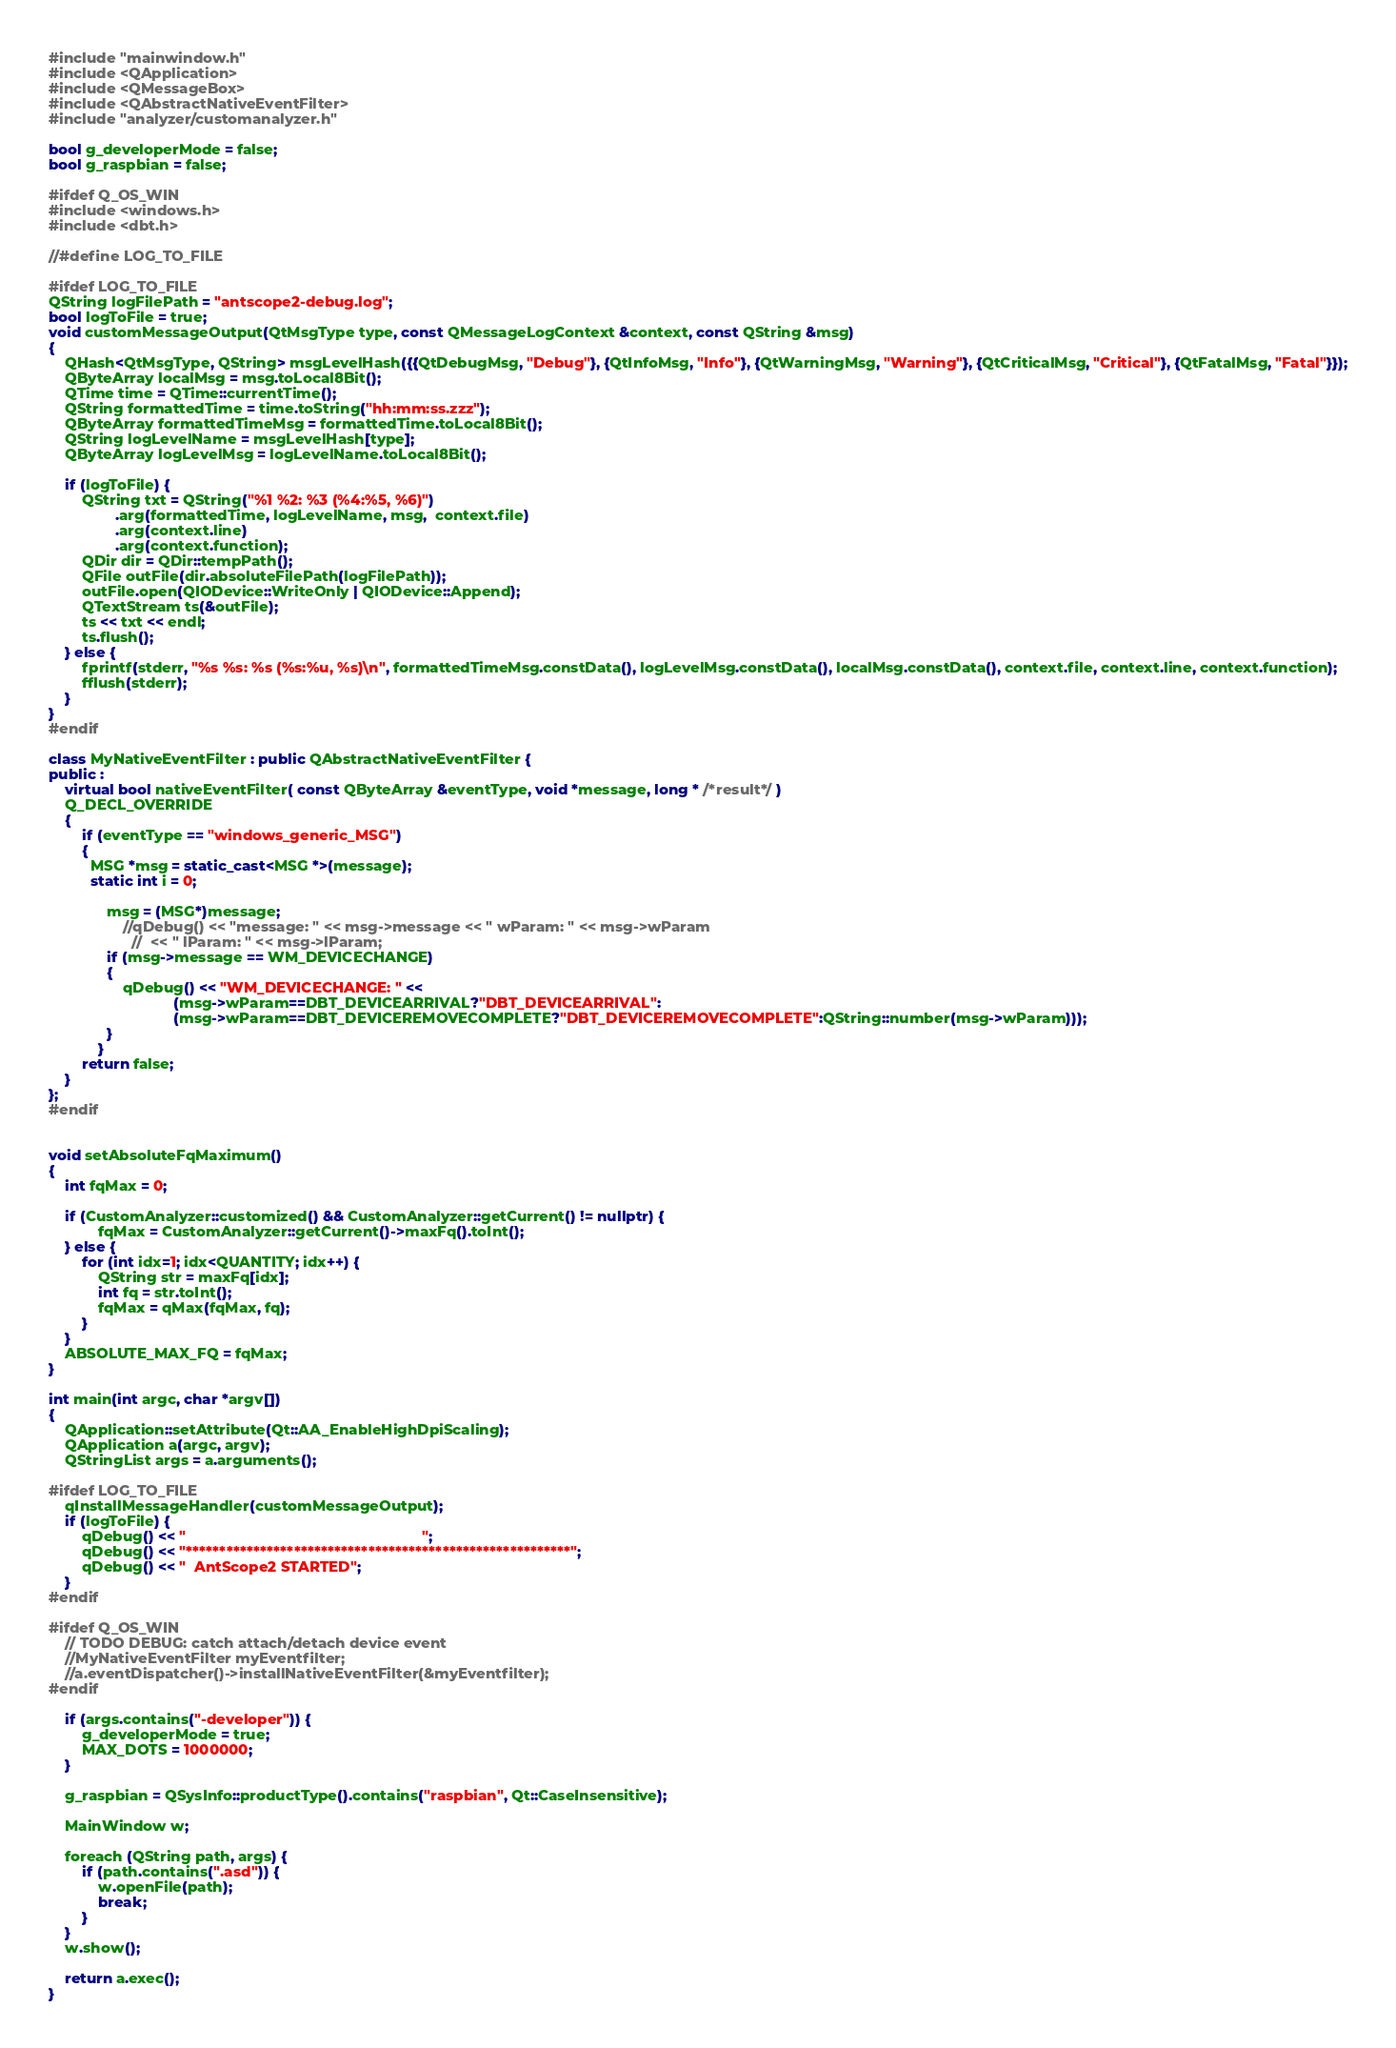Convert code to text. <code><loc_0><loc_0><loc_500><loc_500><_C++_>#include "mainwindow.h"
#include <QApplication>
#include <QMessageBox>
#include <QAbstractNativeEventFilter>
#include "analyzer/customanalyzer.h"

bool g_developerMode = false;
bool g_raspbian = false;

#ifdef Q_OS_WIN
#include <windows.h>
#include <dbt.h>

//#define LOG_TO_FILE

#ifdef LOG_TO_FILE
QString logFilePath = "antscope2-debug.log";
bool logToFile = true;
void customMessageOutput(QtMsgType type, const QMessageLogContext &context, const QString &msg)
{
    QHash<QtMsgType, QString> msgLevelHash({{QtDebugMsg, "Debug"}, {QtInfoMsg, "Info"}, {QtWarningMsg, "Warning"}, {QtCriticalMsg, "Critical"}, {QtFatalMsg, "Fatal"}});
    QByteArray localMsg = msg.toLocal8Bit();
    QTime time = QTime::currentTime();
    QString formattedTime = time.toString("hh:mm:ss.zzz");
    QByteArray formattedTimeMsg = formattedTime.toLocal8Bit();
    QString logLevelName = msgLevelHash[type];
    QByteArray logLevelMsg = logLevelName.toLocal8Bit();

    if (logToFile) {
        QString txt = QString("%1 %2: %3 (%4:%5, %6)")
                .arg(formattedTime, logLevelName, msg,  context.file)
                .arg(context.line)
                .arg(context.function);
        QDir dir = QDir::tempPath();
        QFile outFile(dir.absoluteFilePath(logFilePath));
        outFile.open(QIODevice::WriteOnly | QIODevice::Append);
        QTextStream ts(&outFile);
        ts << txt << endl;
        ts.flush();
    } else {
        fprintf(stderr, "%s %s: %s (%s:%u, %s)\n", formattedTimeMsg.constData(), logLevelMsg.constData(), localMsg.constData(), context.file, context.line, context.function);
        fflush(stderr);
    }
}
#endif

class MyNativeEventFilter : public QAbstractNativeEventFilter {
public :
    virtual bool nativeEventFilter( const QByteArray &eventType, void *message, long * /*result*/ )
    Q_DECL_OVERRIDE
    {
        if (eventType == "windows_generic_MSG")
        {
          MSG *msg = static_cast<MSG *>(message);
          static int i = 0;

              msg = (MSG*)message;
                  //qDebug() << "message: " << msg->message << " wParam: " << msg->wParam
                    //  << " lParam: " << msg->lParam;
              if (msg->message == WM_DEVICECHANGE)
              {
                  qDebug() << "WM_DEVICECHANGE: " <<
                              (msg->wParam==DBT_DEVICEARRIVAL?"DBT_DEVICEARRIVAL":
                              (msg->wParam==DBT_DEVICEREMOVECOMPLETE?"DBT_DEVICEREMOVECOMPLETE":QString::number(msg->wParam)));
              }
            }
        return false;
    }
};
#endif


void setAbsoluteFqMaximum()
{
    int fqMax = 0;

    if (CustomAnalyzer::customized() && CustomAnalyzer::getCurrent() != nullptr) {
            fqMax = CustomAnalyzer::getCurrent()->maxFq().toInt();
    } else {
        for (int idx=1; idx<QUANTITY; idx++) {
            QString str = maxFq[idx];
            int fq = str.toInt();
            fqMax = qMax(fqMax, fq);
        }
    }
    ABSOLUTE_MAX_FQ = fqMax;
}

int main(int argc, char *argv[])
{
    QApplication::setAttribute(Qt::AA_EnableHighDpiScaling);
    QApplication a(argc, argv);
    QStringList args = a.arguments();

#ifdef LOG_TO_FILE
    qInstallMessageHandler(customMessageOutput);
    if (logToFile) {
        qDebug() << "                                                         ";
        qDebug() << "*********************************************************";
        qDebug() << "  AntScope2 STARTED";
    }
#endif

#ifdef Q_OS_WIN
    // TODO DEBUG: catch attach/detach device event
    //MyNativeEventFilter myEventfilter;
    //a.eventDispatcher()->installNativeEventFilter(&myEventfilter);
#endif

    if (args.contains("-developer")) {
        g_developerMode = true;
        MAX_DOTS = 1000000;
    }

    g_raspbian = QSysInfo::productType().contains("raspbian", Qt::CaseInsensitive);

    MainWindow w;

    foreach (QString path, args) {
        if (path.contains(".asd")) {
            w.openFile(path);
            break;
        }
    }
    w.show();

    return a.exec();
}
</code> 